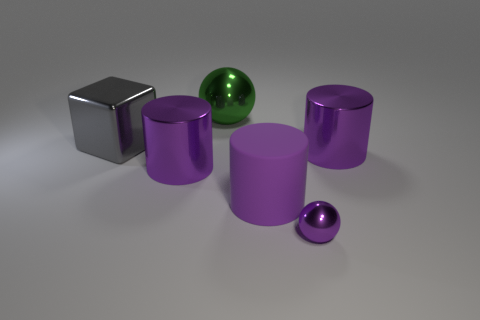What number of other objects are the same color as the rubber object?
Ensure brevity in your answer.  3. Is the color of the tiny sphere the same as the cylinder to the right of the small purple thing?
Provide a short and direct response. Yes. There is a big object that is behind the large cube; does it have the same shape as the small thing?
Your response must be concise. Yes. Is there any other thing that has the same shape as the purple rubber thing?
Provide a short and direct response. Yes. What shape is the large metal thing that is behind the metal block?
Keep it short and to the point. Sphere. Is the shape of the tiny purple object the same as the large green metallic object?
Your answer should be very brief. Yes. The purple object that is the same shape as the green thing is what size?
Offer a very short reply. Small. Do the metal ball right of the green shiny sphere and the big shiny ball have the same size?
Make the answer very short. No. How many metal balls have the same color as the large matte object?
Keep it short and to the point. 1. Are there an equal number of large purple rubber cylinders on the right side of the purple rubber cylinder and cyan spheres?
Your answer should be compact. Yes. 